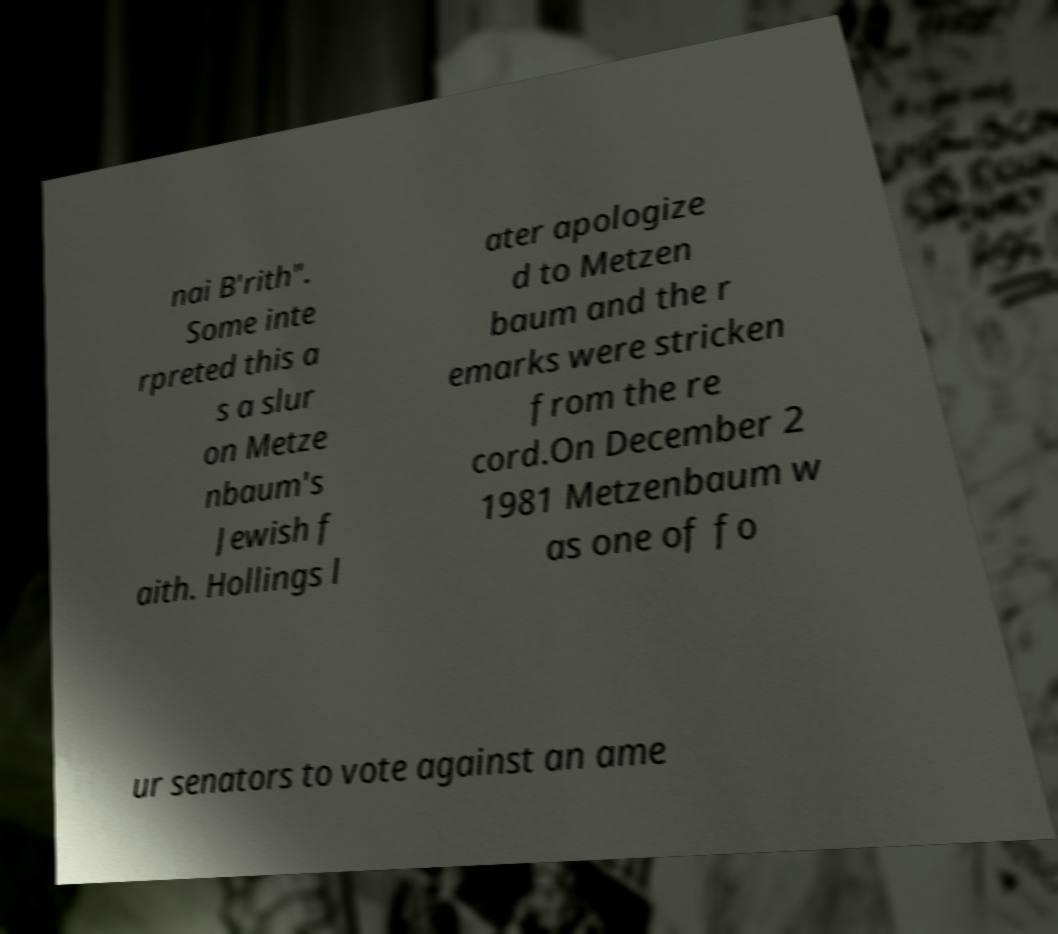There's text embedded in this image that I need extracted. Can you transcribe it verbatim? nai B'rith". Some inte rpreted this a s a slur on Metze nbaum's Jewish f aith. Hollings l ater apologize d to Metzen baum and the r emarks were stricken from the re cord.On December 2 1981 Metzenbaum w as one of fo ur senators to vote against an ame 